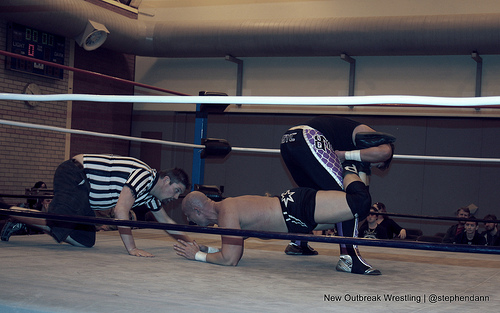<image>
Is there a umpire in front of the wrestler? Yes. The umpire is positioned in front of the wrestler, appearing closer to the camera viewpoint. 